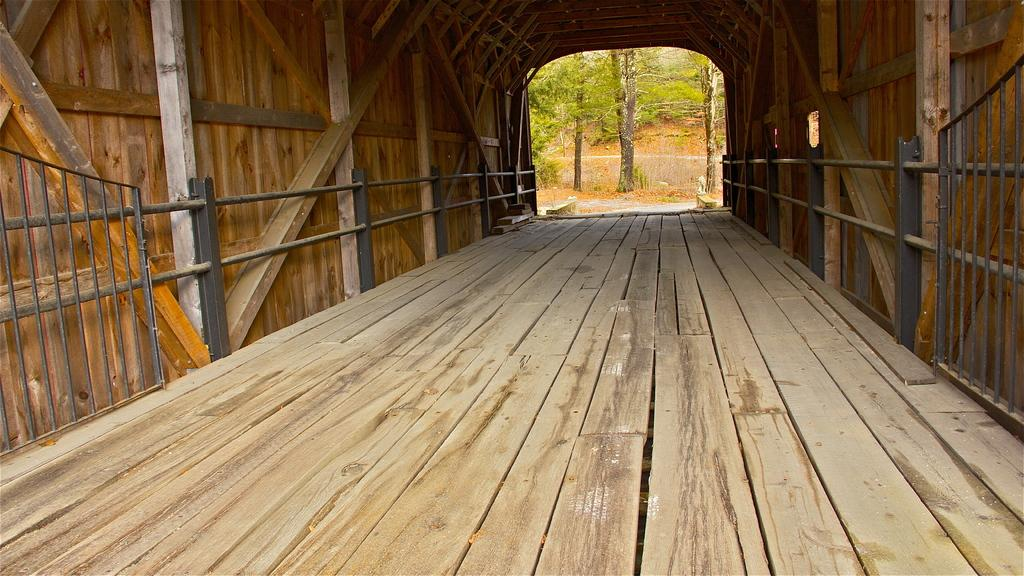What type of path is present in the image? There is a wooden path in the image. What feature can be seen alongside the path? There is a railing visible in the image. What material is used for the wall in the image? There is a wooden wall in the image. What can be seen in the distance in the image? There are many trees in the background of the image. What type of window can be seen in the image? There is no window present in the image. What kind of trouble is depicted in the image? The image does not depict any trouble or problem. 